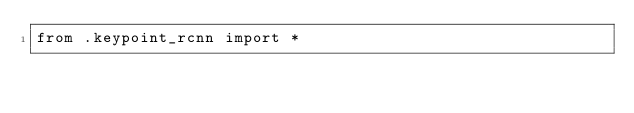<code> <loc_0><loc_0><loc_500><loc_500><_Python_>from .keypoint_rcnn import *</code> 